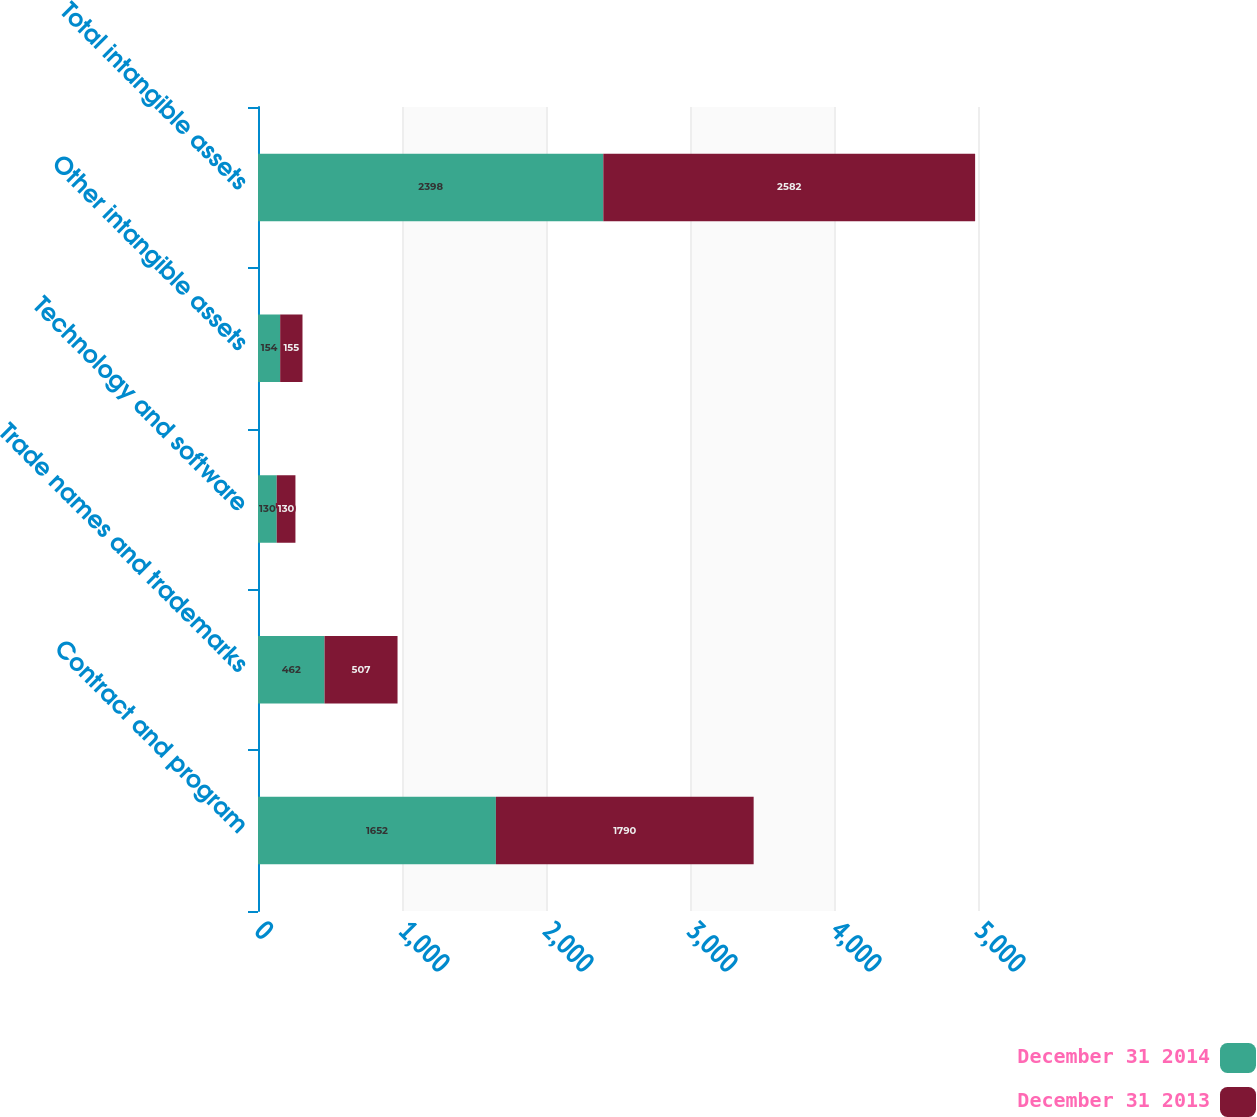<chart> <loc_0><loc_0><loc_500><loc_500><stacked_bar_chart><ecel><fcel>Contract and program<fcel>Trade names and trademarks<fcel>Technology and software<fcel>Other intangible assets<fcel>Total intangible assets<nl><fcel>December 31 2014<fcel>1652<fcel>462<fcel>130<fcel>154<fcel>2398<nl><fcel>December 31 2013<fcel>1790<fcel>507<fcel>130<fcel>155<fcel>2582<nl></chart> 